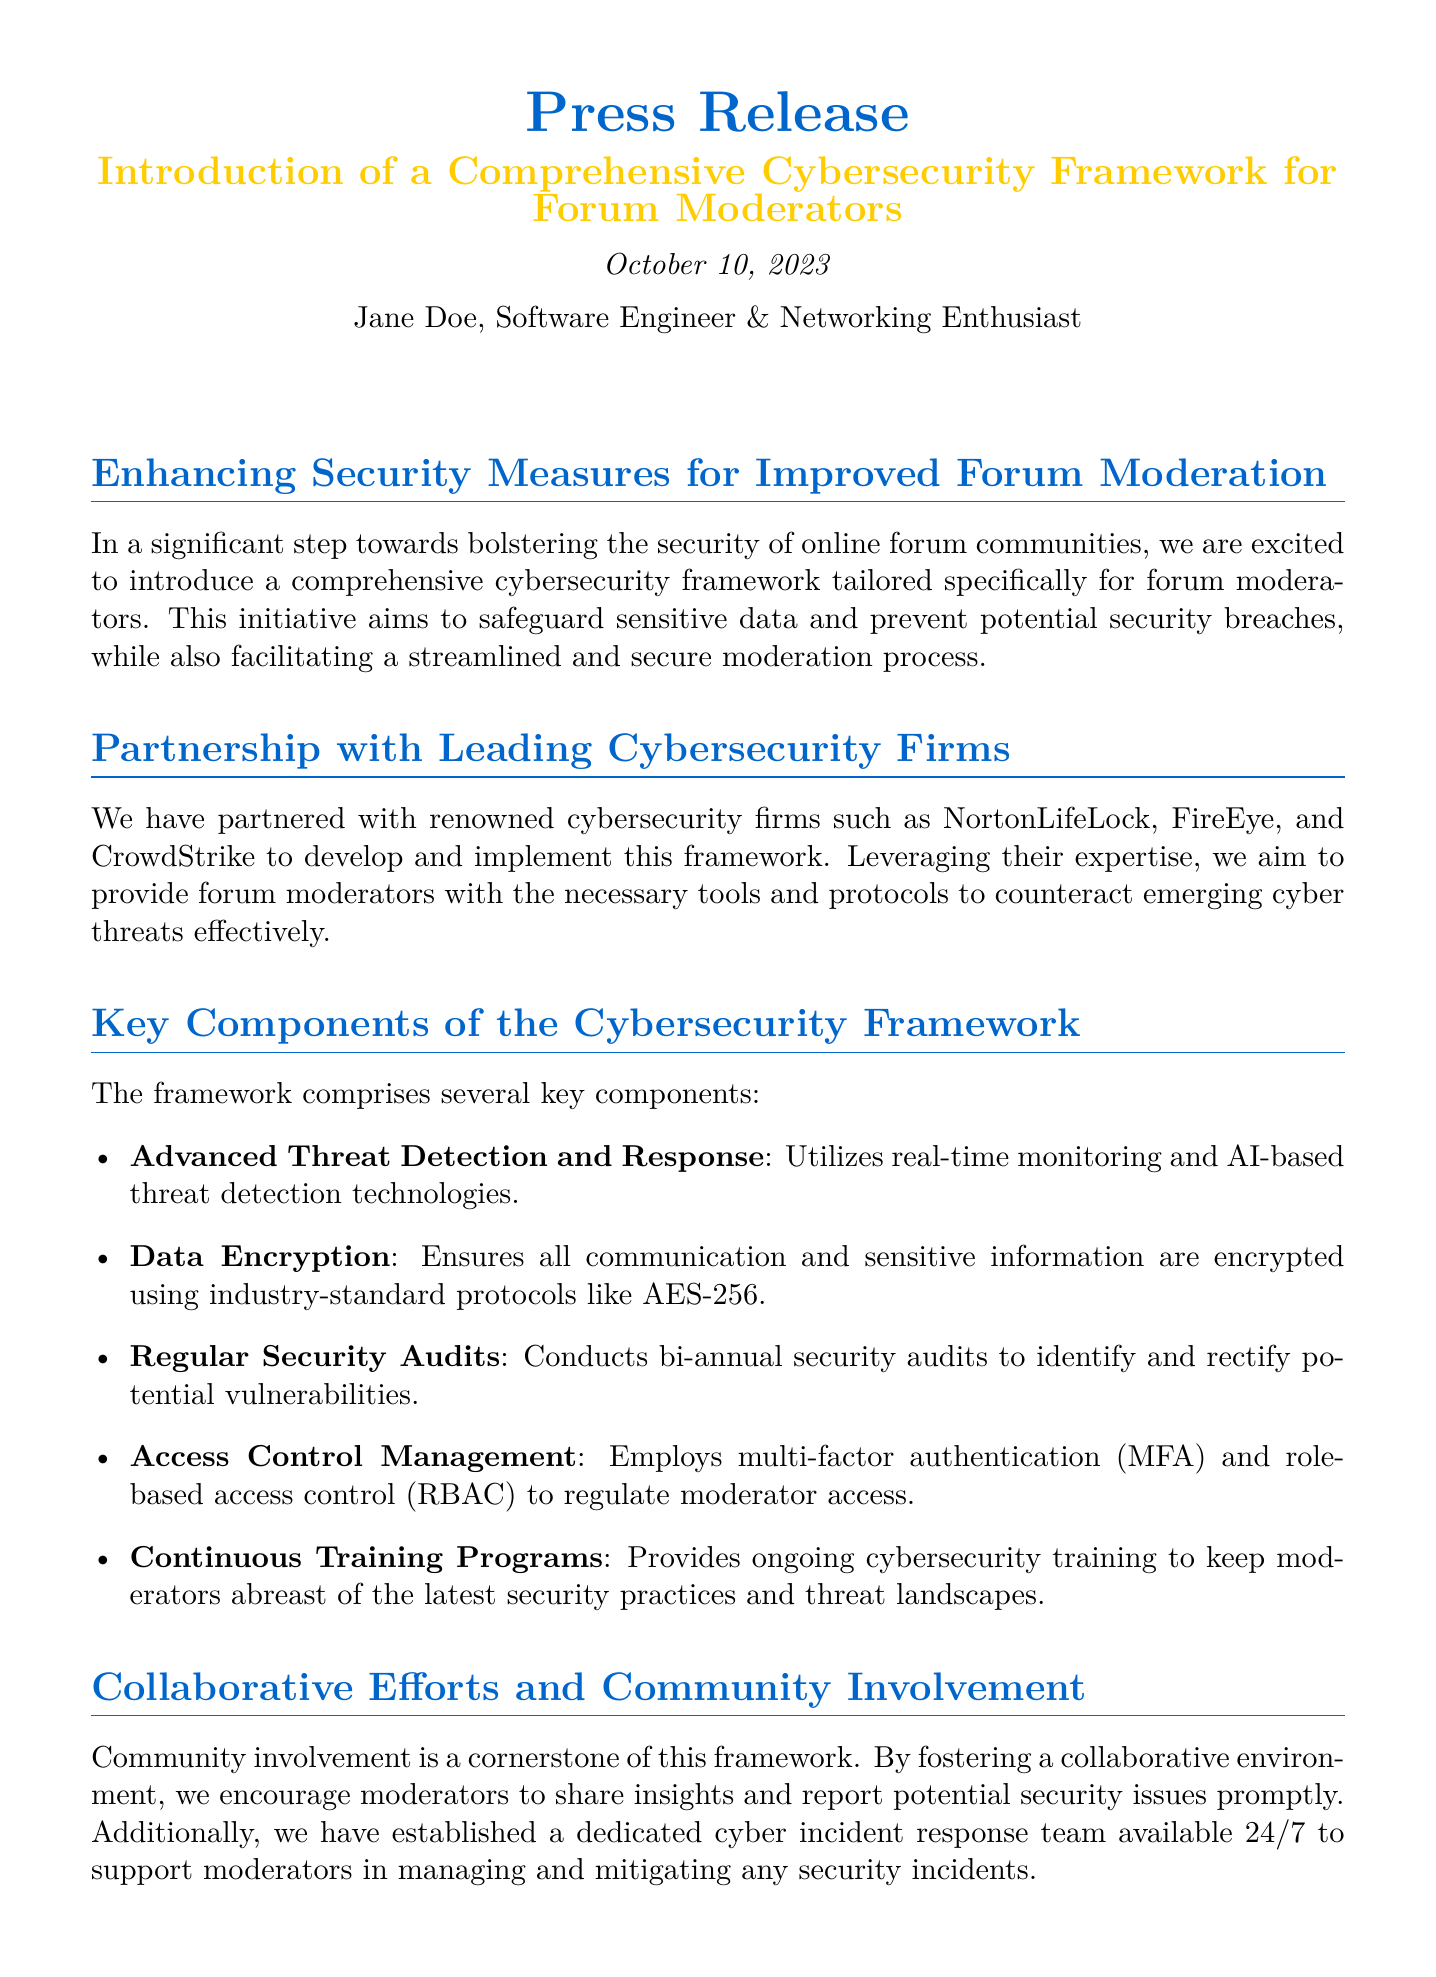What is the purpose of the new cybersecurity framework? The purpose of the framework is to safeguard sensitive data and prevent potential security breaches, while facilitating a streamlined and secure moderation process.
Answer: Safeguard sensitive data Who are the cybersecurity partners mentioned? The document lists NortonLifeLock, FireEye, and CrowdStrike as partners in the development of the framework.
Answer: NortonLifeLock, FireEye, CrowdStrike When was the press release issued? The press release was issued on October 10, 2023, which is explicitly stated in the document.
Answer: October 10, 2023 What is one of the key components of the framework? The framework includes Advanced Threat Detection and Response as one of its key components.
Answer: Advanced Threat Detection and Response Who provided positive feedback about the framework? The document mentions Alice Smith and John Doe as individuals who provided positive feedback.
Answer: Alice Smith, John Doe What method is utilized for data encryption in the framework? The framework uses industry-standard protocols like AES-256 for data encryption.
Answer: AES-256 What ensures moderator access control according to the framework? The framework employs multi-factor authentication (MFA) and role-based access control (RBAC) for access control management.
Answer: Multi-factor authentication (MFA) What is the frequency of the security audits conducted? The document states that regular security audits are conducted bi-annually to identify and rectify potential vulnerabilities.
Answer: Bi-annual 